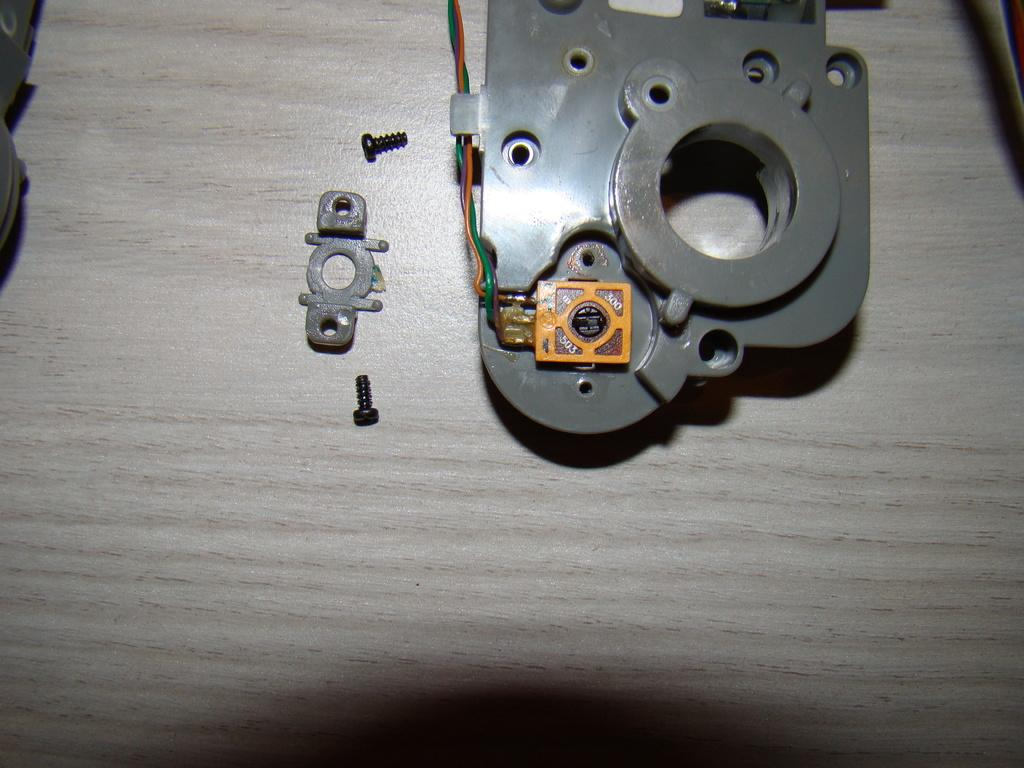What type of food can be seen in the image? There are nuts in the image. What is located on the floor in the image? There is a metal object on the floor in the image. What colors are the objects attached to the metal object? The objects attached to the metal object are red and orange in color. What year is depicted on the faucet in the image? There is no faucet present in the image, so it is not possible to determine the year depicted. 